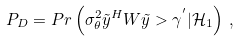<formula> <loc_0><loc_0><loc_500><loc_500>P _ { D } = P r \left ( \sigma _ { \theta } ^ { 2 } \tilde { y } ^ { H } W \tilde { y } > \gamma ^ { ^ { \prime } } | \mathcal { H } _ { 1 } \right ) \, ,</formula> 